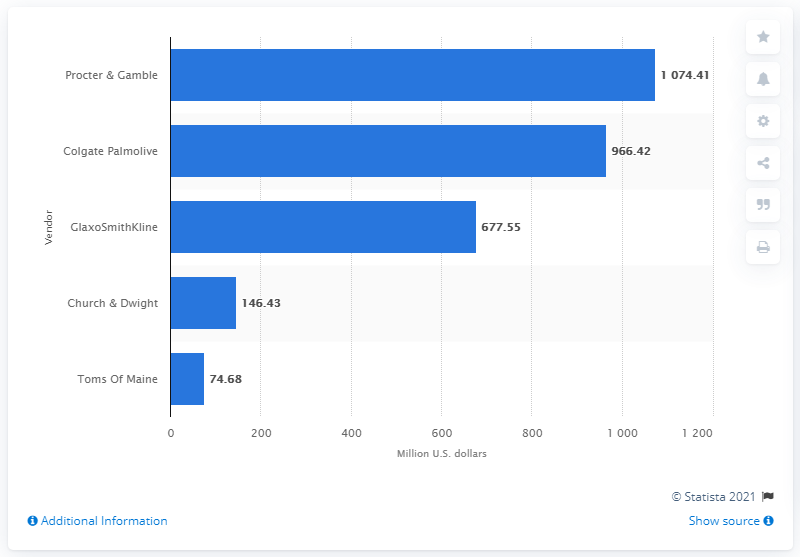Outline some significant characteristics in this image. In 2020, Procter & Gamble was the leading toothpaste vendor in the United States. 